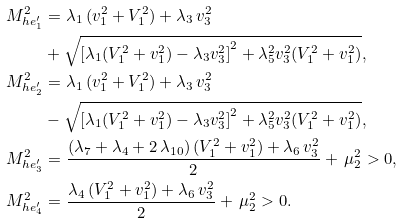Convert formula to latex. <formula><loc_0><loc_0><loc_500><loc_500>M _ { h e ^ { \prime } _ { 1 } } ^ { 2 } & = \lambda _ { 1 } \, ( v _ { 1 } ^ { 2 } + V _ { 1 } ^ { 2 } ) + \lambda _ { 3 } \, v _ { 3 } ^ { 2 } \\ & + \sqrt { \left [ \lambda _ { 1 } ( V _ { 1 } ^ { 2 } + v _ { 1 } ^ { 2 } ) - \lambda _ { 3 } v _ { 3 } ^ { 2 } \right ] ^ { 2 } + \lambda _ { 5 } ^ { 2 } v _ { 3 } ^ { 2 } ( V _ { 1 } ^ { 2 } + v _ { 1 } ^ { 2 } ) } , \\ M _ { h e ^ { \prime } _ { 2 } } ^ { 2 } & = \lambda _ { 1 } \, ( v _ { 1 } ^ { 2 } + V _ { 1 } ^ { 2 } ) + \lambda _ { 3 } \, v _ { 3 } ^ { 2 } \\ & - \sqrt { \left [ \lambda _ { 1 } ( V _ { 1 } ^ { 2 } + v _ { 1 } ^ { 2 } ) - \lambda _ { 3 } v _ { 3 } ^ { 2 } \right ] ^ { 2 } + \lambda _ { 5 } ^ { 2 } v _ { 3 } ^ { 2 } ( V _ { 1 } ^ { 2 } + v _ { 1 } ^ { 2 } ) } , \\ M _ { h e ^ { \prime } _ { 3 } } ^ { 2 } & = \frac { ( \lambda _ { 7 } + \lambda _ { 4 } + 2 \, \lambda _ { 1 0 } ) \, ( V _ { 1 } ^ { 2 } + v _ { 1 } ^ { 2 } ) + \lambda _ { 6 } \, v _ { 3 } ^ { 2 } } { 2 } + \, \mu _ { 2 } ^ { 2 } > 0 , \\ M _ { h e ^ { \prime } _ { 4 } } ^ { 2 } & = \frac { \lambda _ { 4 } \, ( V _ { 1 } ^ { 2 } + v _ { 1 } ^ { 2 } ) + \lambda _ { 6 } \, v _ { 3 } ^ { 2 } } { 2 } + \, \mu _ { 2 } ^ { 2 } > 0 .</formula> 